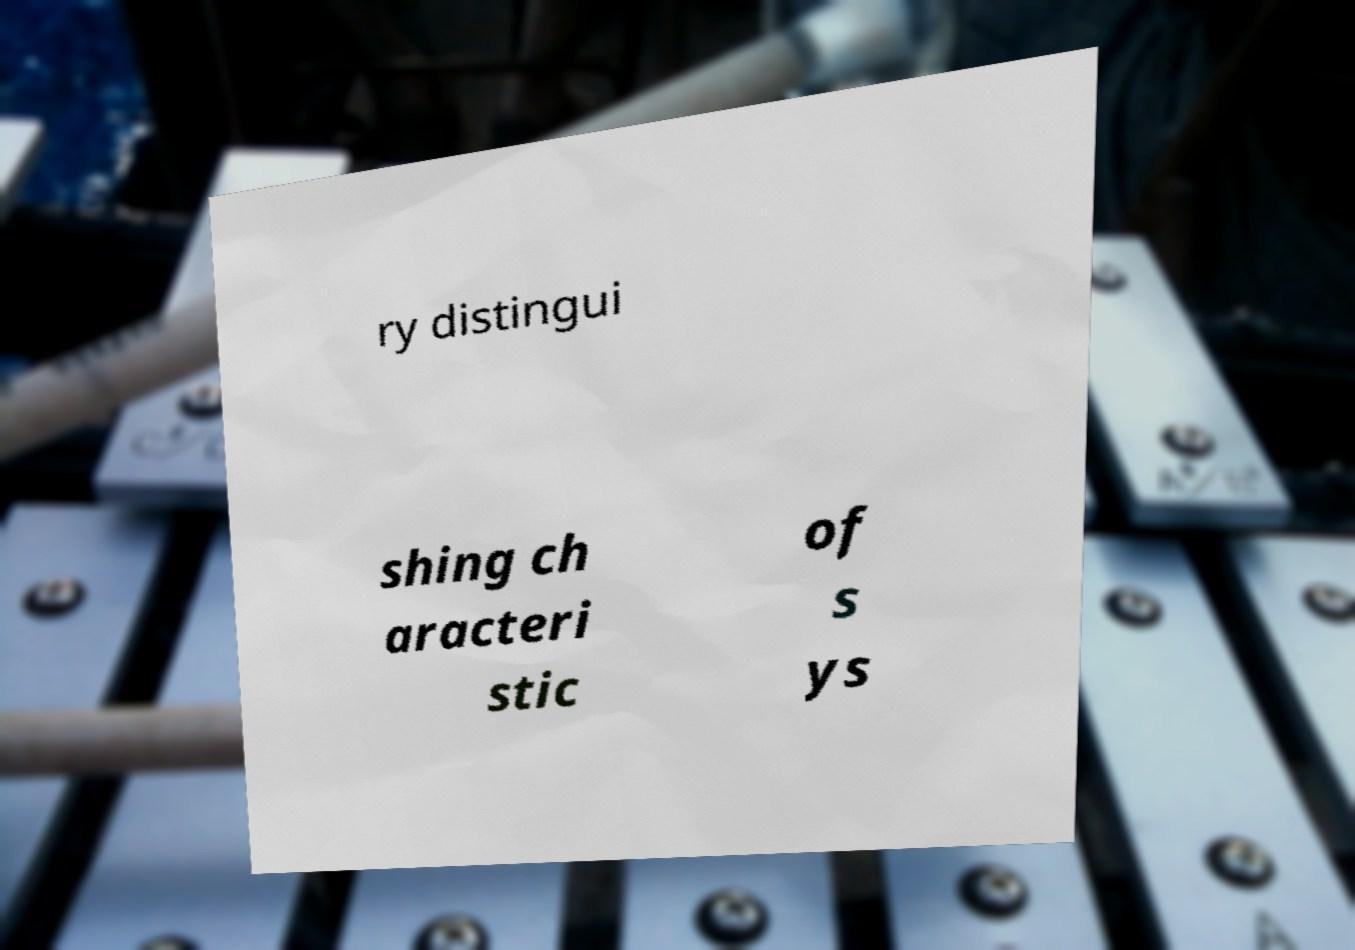Please identify and transcribe the text found in this image. ry distingui shing ch aracteri stic of s ys 